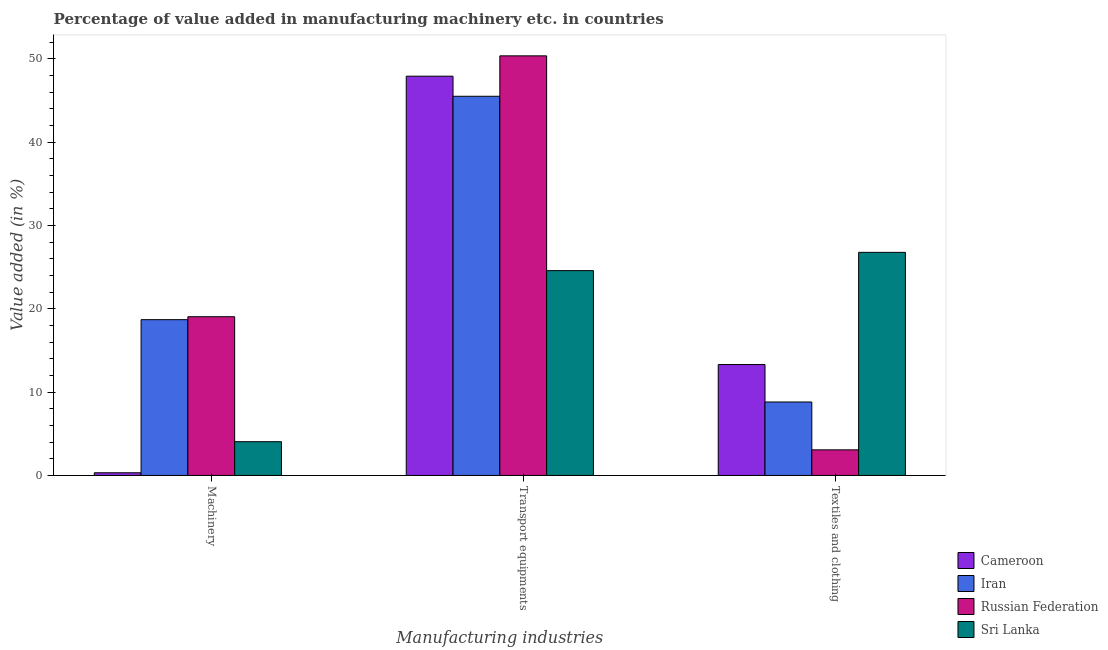How many groups of bars are there?
Your response must be concise. 3. How many bars are there on the 1st tick from the left?
Ensure brevity in your answer.  4. How many bars are there on the 1st tick from the right?
Offer a very short reply. 4. What is the label of the 1st group of bars from the left?
Provide a succinct answer. Machinery. What is the value added in manufacturing textile and clothing in Sri Lanka?
Keep it short and to the point. 26.79. Across all countries, what is the maximum value added in manufacturing textile and clothing?
Your answer should be very brief. 26.79. Across all countries, what is the minimum value added in manufacturing transport equipments?
Your answer should be compact. 24.59. In which country was the value added in manufacturing textile and clothing maximum?
Your answer should be compact. Sri Lanka. In which country was the value added in manufacturing transport equipments minimum?
Provide a short and direct response. Sri Lanka. What is the total value added in manufacturing transport equipments in the graph?
Offer a terse response. 168.42. What is the difference between the value added in manufacturing textile and clothing in Sri Lanka and that in Iran?
Keep it short and to the point. 17.97. What is the difference between the value added in manufacturing machinery in Russian Federation and the value added in manufacturing textile and clothing in Sri Lanka?
Make the answer very short. -7.73. What is the average value added in manufacturing textile and clothing per country?
Provide a succinct answer. 13. What is the difference between the value added in manufacturing transport equipments and value added in manufacturing machinery in Iran?
Make the answer very short. 26.82. What is the ratio of the value added in manufacturing textile and clothing in Iran to that in Sri Lanka?
Your answer should be very brief. 0.33. Is the difference between the value added in manufacturing textile and clothing in Iran and Sri Lanka greater than the difference between the value added in manufacturing transport equipments in Iran and Sri Lanka?
Offer a very short reply. No. What is the difference between the highest and the second highest value added in manufacturing transport equipments?
Your response must be concise. 2.44. What is the difference between the highest and the lowest value added in manufacturing transport equipments?
Make the answer very short. 25.79. In how many countries, is the value added in manufacturing machinery greater than the average value added in manufacturing machinery taken over all countries?
Offer a very short reply. 2. Is the sum of the value added in manufacturing machinery in Iran and Russian Federation greater than the maximum value added in manufacturing textile and clothing across all countries?
Keep it short and to the point. Yes. What does the 4th bar from the left in Textiles and clothing represents?
Provide a succinct answer. Sri Lanka. What does the 1st bar from the right in Machinery represents?
Your answer should be compact. Sri Lanka. Is it the case that in every country, the sum of the value added in manufacturing machinery and value added in manufacturing transport equipments is greater than the value added in manufacturing textile and clothing?
Offer a terse response. Yes. How many bars are there?
Make the answer very short. 12. How many countries are there in the graph?
Offer a very short reply. 4. Does the graph contain any zero values?
Your response must be concise. No. How many legend labels are there?
Give a very brief answer. 4. How are the legend labels stacked?
Your answer should be compact. Vertical. What is the title of the graph?
Your answer should be compact. Percentage of value added in manufacturing machinery etc. in countries. Does "St. Martin (French part)" appear as one of the legend labels in the graph?
Offer a terse response. No. What is the label or title of the X-axis?
Provide a short and direct response. Manufacturing industries. What is the label or title of the Y-axis?
Provide a short and direct response. Value added (in %). What is the Value added (in %) of Cameroon in Machinery?
Your response must be concise. 0.32. What is the Value added (in %) of Iran in Machinery?
Provide a short and direct response. 18.7. What is the Value added (in %) of Russian Federation in Machinery?
Keep it short and to the point. 19.06. What is the Value added (in %) of Sri Lanka in Machinery?
Keep it short and to the point. 4.05. What is the Value added (in %) of Cameroon in Transport equipments?
Ensure brevity in your answer.  47.93. What is the Value added (in %) in Iran in Transport equipments?
Provide a succinct answer. 45.52. What is the Value added (in %) of Russian Federation in Transport equipments?
Your answer should be compact. 50.38. What is the Value added (in %) in Sri Lanka in Transport equipments?
Ensure brevity in your answer.  24.59. What is the Value added (in %) in Cameroon in Textiles and clothing?
Offer a very short reply. 13.31. What is the Value added (in %) of Iran in Textiles and clothing?
Ensure brevity in your answer.  8.82. What is the Value added (in %) in Russian Federation in Textiles and clothing?
Make the answer very short. 3.07. What is the Value added (in %) in Sri Lanka in Textiles and clothing?
Offer a terse response. 26.79. Across all Manufacturing industries, what is the maximum Value added (in %) of Cameroon?
Keep it short and to the point. 47.93. Across all Manufacturing industries, what is the maximum Value added (in %) of Iran?
Your response must be concise. 45.52. Across all Manufacturing industries, what is the maximum Value added (in %) of Russian Federation?
Ensure brevity in your answer.  50.38. Across all Manufacturing industries, what is the maximum Value added (in %) in Sri Lanka?
Your answer should be very brief. 26.79. Across all Manufacturing industries, what is the minimum Value added (in %) in Cameroon?
Keep it short and to the point. 0.32. Across all Manufacturing industries, what is the minimum Value added (in %) in Iran?
Provide a succinct answer. 8.82. Across all Manufacturing industries, what is the minimum Value added (in %) in Russian Federation?
Offer a very short reply. 3.07. Across all Manufacturing industries, what is the minimum Value added (in %) in Sri Lanka?
Give a very brief answer. 4.05. What is the total Value added (in %) of Cameroon in the graph?
Make the answer very short. 61.57. What is the total Value added (in %) in Iran in the graph?
Keep it short and to the point. 73.04. What is the total Value added (in %) in Russian Federation in the graph?
Provide a succinct answer. 72.5. What is the total Value added (in %) of Sri Lanka in the graph?
Provide a succinct answer. 55.43. What is the difference between the Value added (in %) in Cameroon in Machinery and that in Transport equipments?
Your response must be concise. -47.61. What is the difference between the Value added (in %) of Iran in Machinery and that in Transport equipments?
Offer a terse response. -26.82. What is the difference between the Value added (in %) of Russian Federation in Machinery and that in Transport equipments?
Offer a very short reply. -31.32. What is the difference between the Value added (in %) of Sri Lanka in Machinery and that in Transport equipments?
Give a very brief answer. -20.54. What is the difference between the Value added (in %) of Cameroon in Machinery and that in Textiles and clothing?
Provide a succinct answer. -12.99. What is the difference between the Value added (in %) of Iran in Machinery and that in Textiles and clothing?
Your answer should be very brief. 9.88. What is the difference between the Value added (in %) of Russian Federation in Machinery and that in Textiles and clothing?
Offer a very short reply. 15.98. What is the difference between the Value added (in %) in Sri Lanka in Machinery and that in Textiles and clothing?
Make the answer very short. -22.73. What is the difference between the Value added (in %) in Cameroon in Transport equipments and that in Textiles and clothing?
Provide a short and direct response. 34.62. What is the difference between the Value added (in %) in Iran in Transport equipments and that in Textiles and clothing?
Ensure brevity in your answer.  36.71. What is the difference between the Value added (in %) of Russian Federation in Transport equipments and that in Textiles and clothing?
Provide a succinct answer. 47.3. What is the difference between the Value added (in %) in Sri Lanka in Transport equipments and that in Textiles and clothing?
Keep it short and to the point. -2.2. What is the difference between the Value added (in %) in Cameroon in Machinery and the Value added (in %) in Iran in Transport equipments?
Your answer should be compact. -45.2. What is the difference between the Value added (in %) of Cameroon in Machinery and the Value added (in %) of Russian Federation in Transport equipments?
Provide a succinct answer. -50.06. What is the difference between the Value added (in %) of Cameroon in Machinery and the Value added (in %) of Sri Lanka in Transport equipments?
Ensure brevity in your answer.  -24.27. What is the difference between the Value added (in %) of Iran in Machinery and the Value added (in %) of Russian Federation in Transport equipments?
Your response must be concise. -31.67. What is the difference between the Value added (in %) in Iran in Machinery and the Value added (in %) in Sri Lanka in Transport equipments?
Make the answer very short. -5.89. What is the difference between the Value added (in %) in Russian Federation in Machinery and the Value added (in %) in Sri Lanka in Transport equipments?
Offer a very short reply. -5.53. What is the difference between the Value added (in %) of Cameroon in Machinery and the Value added (in %) of Iran in Textiles and clothing?
Keep it short and to the point. -8.5. What is the difference between the Value added (in %) in Cameroon in Machinery and the Value added (in %) in Russian Federation in Textiles and clothing?
Provide a short and direct response. -2.75. What is the difference between the Value added (in %) of Cameroon in Machinery and the Value added (in %) of Sri Lanka in Textiles and clothing?
Ensure brevity in your answer.  -26.46. What is the difference between the Value added (in %) of Iran in Machinery and the Value added (in %) of Russian Federation in Textiles and clothing?
Your answer should be compact. 15.63. What is the difference between the Value added (in %) of Iran in Machinery and the Value added (in %) of Sri Lanka in Textiles and clothing?
Give a very brief answer. -8.08. What is the difference between the Value added (in %) of Russian Federation in Machinery and the Value added (in %) of Sri Lanka in Textiles and clothing?
Provide a short and direct response. -7.73. What is the difference between the Value added (in %) in Cameroon in Transport equipments and the Value added (in %) in Iran in Textiles and clothing?
Your answer should be compact. 39.12. What is the difference between the Value added (in %) of Cameroon in Transport equipments and the Value added (in %) of Russian Federation in Textiles and clothing?
Give a very brief answer. 44.86. What is the difference between the Value added (in %) of Cameroon in Transport equipments and the Value added (in %) of Sri Lanka in Textiles and clothing?
Offer a very short reply. 21.15. What is the difference between the Value added (in %) of Iran in Transport equipments and the Value added (in %) of Russian Federation in Textiles and clothing?
Provide a short and direct response. 42.45. What is the difference between the Value added (in %) in Iran in Transport equipments and the Value added (in %) in Sri Lanka in Textiles and clothing?
Your answer should be compact. 18.74. What is the difference between the Value added (in %) in Russian Federation in Transport equipments and the Value added (in %) in Sri Lanka in Textiles and clothing?
Your answer should be compact. 23.59. What is the average Value added (in %) in Cameroon per Manufacturing industries?
Give a very brief answer. 20.52. What is the average Value added (in %) of Iran per Manufacturing industries?
Give a very brief answer. 24.35. What is the average Value added (in %) of Russian Federation per Manufacturing industries?
Ensure brevity in your answer.  24.17. What is the average Value added (in %) in Sri Lanka per Manufacturing industries?
Your answer should be very brief. 18.48. What is the difference between the Value added (in %) of Cameroon and Value added (in %) of Iran in Machinery?
Your response must be concise. -18.38. What is the difference between the Value added (in %) in Cameroon and Value added (in %) in Russian Federation in Machinery?
Your response must be concise. -18.73. What is the difference between the Value added (in %) of Cameroon and Value added (in %) of Sri Lanka in Machinery?
Provide a succinct answer. -3.73. What is the difference between the Value added (in %) in Iran and Value added (in %) in Russian Federation in Machinery?
Your answer should be compact. -0.35. What is the difference between the Value added (in %) in Iran and Value added (in %) in Sri Lanka in Machinery?
Your answer should be very brief. 14.65. What is the difference between the Value added (in %) in Russian Federation and Value added (in %) in Sri Lanka in Machinery?
Your answer should be compact. 15. What is the difference between the Value added (in %) in Cameroon and Value added (in %) in Iran in Transport equipments?
Make the answer very short. 2.41. What is the difference between the Value added (in %) in Cameroon and Value added (in %) in Russian Federation in Transport equipments?
Offer a terse response. -2.44. What is the difference between the Value added (in %) in Cameroon and Value added (in %) in Sri Lanka in Transport equipments?
Give a very brief answer. 23.34. What is the difference between the Value added (in %) of Iran and Value added (in %) of Russian Federation in Transport equipments?
Ensure brevity in your answer.  -4.85. What is the difference between the Value added (in %) in Iran and Value added (in %) in Sri Lanka in Transport equipments?
Offer a terse response. 20.93. What is the difference between the Value added (in %) of Russian Federation and Value added (in %) of Sri Lanka in Transport equipments?
Give a very brief answer. 25.79. What is the difference between the Value added (in %) of Cameroon and Value added (in %) of Iran in Textiles and clothing?
Your answer should be very brief. 4.5. What is the difference between the Value added (in %) in Cameroon and Value added (in %) in Russian Federation in Textiles and clothing?
Provide a short and direct response. 10.24. What is the difference between the Value added (in %) in Cameroon and Value added (in %) in Sri Lanka in Textiles and clothing?
Keep it short and to the point. -13.47. What is the difference between the Value added (in %) in Iran and Value added (in %) in Russian Federation in Textiles and clothing?
Keep it short and to the point. 5.75. What is the difference between the Value added (in %) in Iran and Value added (in %) in Sri Lanka in Textiles and clothing?
Provide a succinct answer. -17.97. What is the difference between the Value added (in %) of Russian Federation and Value added (in %) of Sri Lanka in Textiles and clothing?
Make the answer very short. -23.71. What is the ratio of the Value added (in %) of Cameroon in Machinery to that in Transport equipments?
Your response must be concise. 0.01. What is the ratio of the Value added (in %) in Iran in Machinery to that in Transport equipments?
Ensure brevity in your answer.  0.41. What is the ratio of the Value added (in %) in Russian Federation in Machinery to that in Transport equipments?
Make the answer very short. 0.38. What is the ratio of the Value added (in %) in Sri Lanka in Machinery to that in Transport equipments?
Your response must be concise. 0.16. What is the ratio of the Value added (in %) of Cameroon in Machinery to that in Textiles and clothing?
Your response must be concise. 0.02. What is the ratio of the Value added (in %) in Iran in Machinery to that in Textiles and clothing?
Offer a very short reply. 2.12. What is the ratio of the Value added (in %) in Russian Federation in Machinery to that in Textiles and clothing?
Provide a short and direct response. 6.2. What is the ratio of the Value added (in %) of Sri Lanka in Machinery to that in Textiles and clothing?
Your answer should be compact. 0.15. What is the ratio of the Value added (in %) in Cameroon in Transport equipments to that in Textiles and clothing?
Keep it short and to the point. 3.6. What is the ratio of the Value added (in %) of Iran in Transport equipments to that in Textiles and clothing?
Your answer should be compact. 5.16. What is the ratio of the Value added (in %) of Russian Federation in Transport equipments to that in Textiles and clothing?
Ensure brevity in your answer.  16.4. What is the ratio of the Value added (in %) in Sri Lanka in Transport equipments to that in Textiles and clothing?
Your response must be concise. 0.92. What is the difference between the highest and the second highest Value added (in %) in Cameroon?
Give a very brief answer. 34.62. What is the difference between the highest and the second highest Value added (in %) of Iran?
Your answer should be very brief. 26.82. What is the difference between the highest and the second highest Value added (in %) in Russian Federation?
Your answer should be compact. 31.32. What is the difference between the highest and the second highest Value added (in %) in Sri Lanka?
Offer a terse response. 2.2. What is the difference between the highest and the lowest Value added (in %) of Cameroon?
Your answer should be very brief. 47.61. What is the difference between the highest and the lowest Value added (in %) in Iran?
Your response must be concise. 36.71. What is the difference between the highest and the lowest Value added (in %) of Russian Federation?
Your answer should be compact. 47.3. What is the difference between the highest and the lowest Value added (in %) in Sri Lanka?
Make the answer very short. 22.73. 